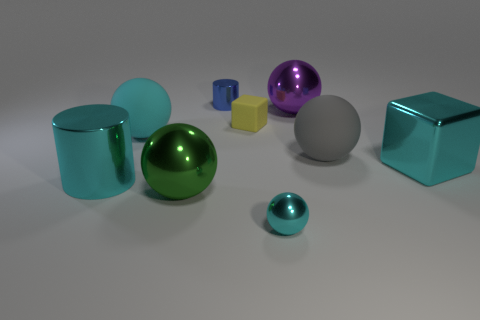Subtract all cyan balls. How many were subtracted if there are1cyan balls left? 1 Add 1 brown cylinders. How many objects exist? 10 Subtract all cubes. How many objects are left? 7 Subtract all small purple spheres. Subtract all yellow objects. How many objects are left? 8 Add 5 cubes. How many cubes are left? 7 Add 6 big green shiny blocks. How many big green shiny blocks exist? 6 Subtract 1 yellow blocks. How many objects are left? 8 